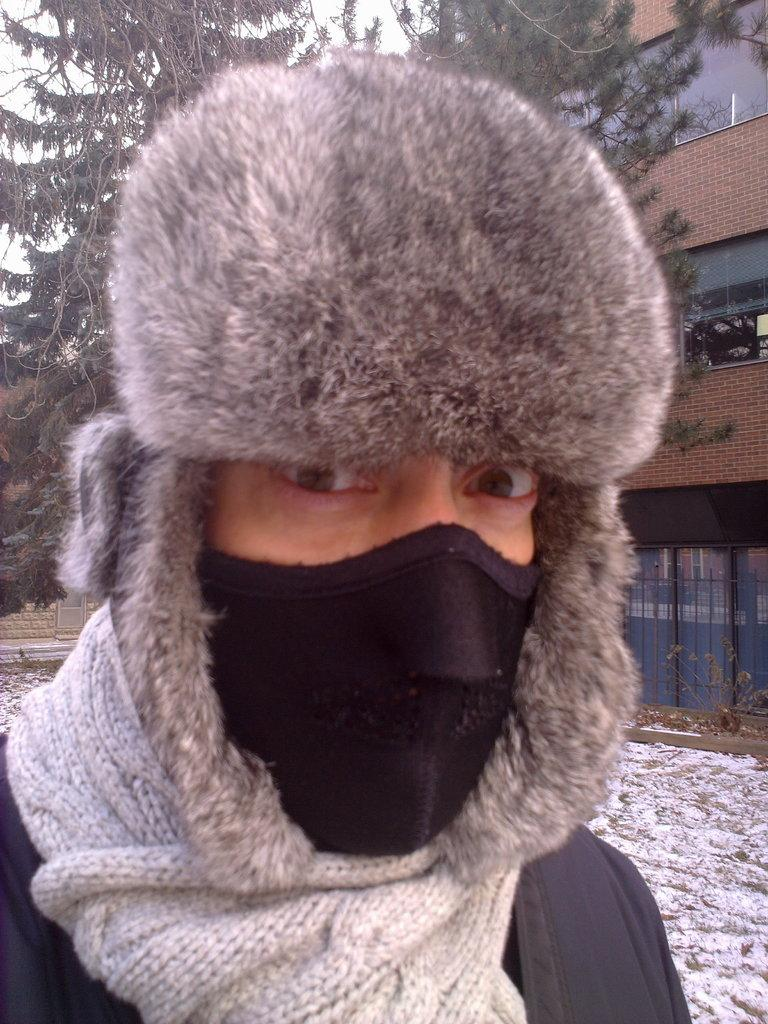What is the main subject of the image? There is a person in the image. What is the person wearing on their face? The person is wearing a mask on their face. What type of headwear is the person wearing? The person is wearing a cap. What can be seen in the background of the image? There is ground, at least one building, trees, and the sky visible in the background of the image. Are there any objects in the background of the image? Yes, there are some objects in the background of the image. What is the person's sister doing in the image? There is no mention of a sister in the image, so it cannot be determined what the sister might be doing. 